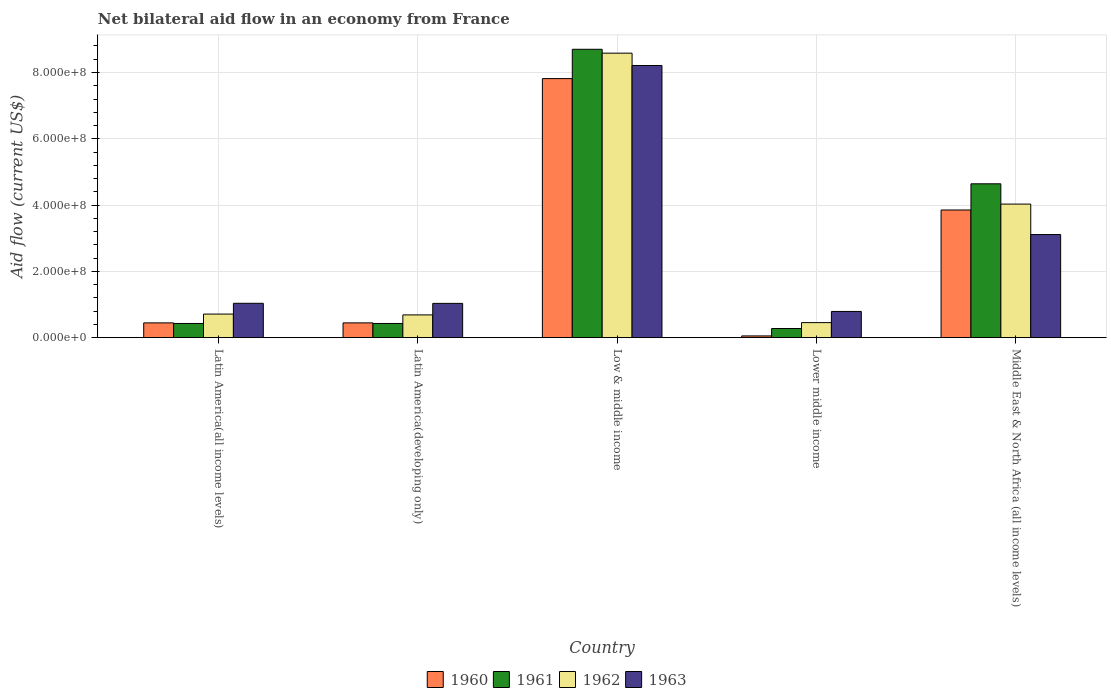How many bars are there on the 1st tick from the left?
Offer a terse response. 4. How many bars are there on the 3rd tick from the right?
Give a very brief answer. 4. What is the label of the 4th group of bars from the left?
Your answer should be very brief. Lower middle income. In how many cases, is the number of bars for a given country not equal to the number of legend labels?
Offer a very short reply. 0. What is the net bilateral aid flow in 1962 in Lower middle income?
Offer a very short reply. 4.54e+07. Across all countries, what is the maximum net bilateral aid flow in 1961?
Your answer should be compact. 8.70e+08. Across all countries, what is the minimum net bilateral aid flow in 1961?
Offer a terse response. 2.76e+07. In which country was the net bilateral aid flow in 1963 minimum?
Offer a very short reply. Lower middle income. What is the total net bilateral aid flow in 1962 in the graph?
Your response must be concise. 1.45e+09. What is the difference between the net bilateral aid flow in 1963 in Latin America(developing only) and that in Lower middle income?
Keep it short and to the point. 2.43e+07. What is the difference between the net bilateral aid flow in 1963 in Latin America(all income levels) and the net bilateral aid flow in 1962 in Lower middle income?
Provide a succinct answer. 5.83e+07. What is the average net bilateral aid flow in 1962 per country?
Ensure brevity in your answer.  2.89e+08. What is the difference between the net bilateral aid flow of/in 1963 and net bilateral aid flow of/in 1962 in Middle East & North Africa (all income levels)?
Offer a very short reply. -9.19e+07. Is the net bilateral aid flow in 1960 in Latin America(all income levels) less than that in Middle East & North Africa (all income levels)?
Your answer should be compact. Yes. Is the difference between the net bilateral aid flow in 1963 in Latin America(all income levels) and Middle East & North Africa (all income levels) greater than the difference between the net bilateral aid flow in 1962 in Latin America(all income levels) and Middle East & North Africa (all income levels)?
Make the answer very short. Yes. What is the difference between the highest and the second highest net bilateral aid flow in 1963?
Give a very brief answer. 7.17e+08. What is the difference between the highest and the lowest net bilateral aid flow in 1963?
Ensure brevity in your answer.  7.42e+08. What does the 4th bar from the right in Latin America(developing only) represents?
Provide a short and direct response. 1960. How many bars are there?
Your answer should be compact. 20. How many countries are there in the graph?
Make the answer very short. 5. How many legend labels are there?
Keep it short and to the point. 4. What is the title of the graph?
Give a very brief answer. Net bilateral aid flow in an economy from France. Does "1964" appear as one of the legend labels in the graph?
Keep it short and to the point. No. What is the Aid flow (current US$) in 1960 in Latin America(all income levels)?
Provide a succinct answer. 4.46e+07. What is the Aid flow (current US$) of 1961 in Latin America(all income levels)?
Your response must be concise. 4.28e+07. What is the Aid flow (current US$) of 1962 in Latin America(all income levels)?
Provide a succinct answer. 7.12e+07. What is the Aid flow (current US$) of 1963 in Latin America(all income levels)?
Offer a terse response. 1.04e+08. What is the Aid flow (current US$) in 1960 in Latin America(developing only)?
Give a very brief answer. 4.46e+07. What is the Aid flow (current US$) in 1961 in Latin America(developing only)?
Your response must be concise. 4.28e+07. What is the Aid flow (current US$) in 1962 in Latin America(developing only)?
Make the answer very short. 6.87e+07. What is the Aid flow (current US$) of 1963 in Latin America(developing only)?
Offer a terse response. 1.03e+08. What is the Aid flow (current US$) of 1960 in Low & middle income?
Your response must be concise. 7.82e+08. What is the Aid flow (current US$) in 1961 in Low & middle income?
Keep it short and to the point. 8.70e+08. What is the Aid flow (current US$) of 1962 in Low & middle income?
Offer a terse response. 8.58e+08. What is the Aid flow (current US$) of 1963 in Low & middle income?
Offer a terse response. 8.21e+08. What is the Aid flow (current US$) in 1960 in Lower middle income?
Your answer should be compact. 5.30e+06. What is the Aid flow (current US$) in 1961 in Lower middle income?
Your response must be concise. 2.76e+07. What is the Aid flow (current US$) in 1962 in Lower middle income?
Your response must be concise. 4.54e+07. What is the Aid flow (current US$) of 1963 in Lower middle income?
Offer a very short reply. 7.91e+07. What is the Aid flow (current US$) of 1960 in Middle East & North Africa (all income levels)?
Provide a succinct answer. 3.85e+08. What is the Aid flow (current US$) of 1961 in Middle East & North Africa (all income levels)?
Offer a terse response. 4.64e+08. What is the Aid flow (current US$) in 1962 in Middle East & North Africa (all income levels)?
Keep it short and to the point. 4.03e+08. What is the Aid flow (current US$) in 1963 in Middle East & North Africa (all income levels)?
Your response must be concise. 3.11e+08. Across all countries, what is the maximum Aid flow (current US$) in 1960?
Ensure brevity in your answer.  7.82e+08. Across all countries, what is the maximum Aid flow (current US$) in 1961?
Your answer should be compact. 8.70e+08. Across all countries, what is the maximum Aid flow (current US$) of 1962?
Offer a very short reply. 8.58e+08. Across all countries, what is the maximum Aid flow (current US$) in 1963?
Your answer should be very brief. 8.21e+08. Across all countries, what is the minimum Aid flow (current US$) in 1960?
Give a very brief answer. 5.30e+06. Across all countries, what is the minimum Aid flow (current US$) of 1961?
Make the answer very short. 2.76e+07. Across all countries, what is the minimum Aid flow (current US$) in 1962?
Your answer should be very brief. 4.54e+07. Across all countries, what is the minimum Aid flow (current US$) of 1963?
Your answer should be very brief. 7.91e+07. What is the total Aid flow (current US$) of 1960 in the graph?
Ensure brevity in your answer.  1.26e+09. What is the total Aid flow (current US$) in 1961 in the graph?
Provide a succinct answer. 1.45e+09. What is the total Aid flow (current US$) in 1962 in the graph?
Your answer should be compact. 1.45e+09. What is the total Aid flow (current US$) in 1963 in the graph?
Provide a succinct answer. 1.42e+09. What is the difference between the Aid flow (current US$) of 1960 in Latin America(all income levels) and that in Latin America(developing only)?
Offer a very short reply. 0. What is the difference between the Aid flow (current US$) of 1961 in Latin America(all income levels) and that in Latin America(developing only)?
Give a very brief answer. 0. What is the difference between the Aid flow (current US$) of 1962 in Latin America(all income levels) and that in Latin America(developing only)?
Provide a succinct answer. 2.50e+06. What is the difference between the Aid flow (current US$) in 1963 in Latin America(all income levels) and that in Latin America(developing only)?
Your response must be concise. 3.00e+05. What is the difference between the Aid flow (current US$) of 1960 in Latin America(all income levels) and that in Low & middle income?
Provide a short and direct response. -7.37e+08. What is the difference between the Aid flow (current US$) of 1961 in Latin America(all income levels) and that in Low & middle income?
Your answer should be very brief. -8.27e+08. What is the difference between the Aid flow (current US$) in 1962 in Latin America(all income levels) and that in Low & middle income?
Keep it short and to the point. -7.87e+08. What is the difference between the Aid flow (current US$) in 1963 in Latin America(all income levels) and that in Low & middle income?
Your answer should be very brief. -7.17e+08. What is the difference between the Aid flow (current US$) in 1960 in Latin America(all income levels) and that in Lower middle income?
Give a very brief answer. 3.93e+07. What is the difference between the Aid flow (current US$) of 1961 in Latin America(all income levels) and that in Lower middle income?
Keep it short and to the point. 1.52e+07. What is the difference between the Aid flow (current US$) in 1962 in Latin America(all income levels) and that in Lower middle income?
Your answer should be very brief. 2.58e+07. What is the difference between the Aid flow (current US$) in 1963 in Latin America(all income levels) and that in Lower middle income?
Offer a very short reply. 2.46e+07. What is the difference between the Aid flow (current US$) in 1960 in Latin America(all income levels) and that in Middle East & North Africa (all income levels)?
Ensure brevity in your answer.  -3.41e+08. What is the difference between the Aid flow (current US$) in 1961 in Latin America(all income levels) and that in Middle East & North Africa (all income levels)?
Make the answer very short. -4.21e+08. What is the difference between the Aid flow (current US$) in 1962 in Latin America(all income levels) and that in Middle East & North Africa (all income levels)?
Keep it short and to the point. -3.32e+08. What is the difference between the Aid flow (current US$) in 1963 in Latin America(all income levels) and that in Middle East & North Africa (all income levels)?
Give a very brief answer. -2.07e+08. What is the difference between the Aid flow (current US$) in 1960 in Latin America(developing only) and that in Low & middle income?
Provide a short and direct response. -7.37e+08. What is the difference between the Aid flow (current US$) of 1961 in Latin America(developing only) and that in Low & middle income?
Your response must be concise. -8.27e+08. What is the difference between the Aid flow (current US$) of 1962 in Latin America(developing only) and that in Low & middle income?
Offer a very short reply. -7.90e+08. What is the difference between the Aid flow (current US$) of 1963 in Latin America(developing only) and that in Low & middle income?
Give a very brief answer. -7.18e+08. What is the difference between the Aid flow (current US$) in 1960 in Latin America(developing only) and that in Lower middle income?
Your answer should be very brief. 3.93e+07. What is the difference between the Aid flow (current US$) in 1961 in Latin America(developing only) and that in Lower middle income?
Provide a short and direct response. 1.52e+07. What is the difference between the Aid flow (current US$) in 1962 in Latin America(developing only) and that in Lower middle income?
Your answer should be compact. 2.33e+07. What is the difference between the Aid flow (current US$) in 1963 in Latin America(developing only) and that in Lower middle income?
Ensure brevity in your answer.  2.43e+07. What is the difference between the Aid flow (current US$) in 1960 in Latin America(developing only) and that in Middle East & North Africa (all income levels)?
Keep it short and to the point. -3.41e+08. What is the difference between the Aid flow (current US$) in 1961 in Latin America(developing only) and that in Middle East & North Africa (all income levels)?
Make the answer very short. -4.21e+08. What is the difference between the Aid flow (current US$) in 1962 in Latin America(developing only) and that in Middle East & North Africa (all income levels)?
Provide a succinct answer. -3.34e+08. What is the difference between the Aid flow (current US$) of 1963 in Latin America(developing only) and that in Middle East & North Africa (all income levels)?
Offer a terse response. -2.08e+08. What is the difference between the Aid flow (current US$) in 1960 in Low & middle income and that in Lower middle income?
Keep it short and to the point. 7.76e+08. What is the difference between the Aid flow (current US$) of 1961 in Low & middle income and that in Lower middle income?
Offer a very short reply. 8.42e+08. What is the difference between the Aid flow (current US$) in 1962 in Low & middle income and that in Lower middle income?
Provide a succinct answer. 8.13e+08. What is the difference between the Aid flow (current US$) in 1963 in Low & middle income and that in Lower middle income?
Give a very brief answer. 7.42e+08. What is the difference between the Aid flow (current US$) in 1960 in Low & middle income and that in Middle East & North Africa (all income levels)?
Your response must be concise. 3.96e+08. What is the difference between the Aid flow (current US$) in 1961 in Low & middle income and that in Middle East & North Africa (all income levels)?
Make the answer very short. 4.06e+08. What is the difference between the Aid flow (current US$) of 1962 in Low & middle income and that in Middle East & North Africa (all income levels)?
Offer a terse response. 4.55e+08. What is the difference between the Aid flow (current US$) of 1963 in Low & middle income and that in Middle East & North Africa (all income levels)?
Provide a succinct answer. 5.10e+08. What is the difference between the Aid flow (current US$) of 1960 in Lower middle income and that in Middle East & North Africa (all income levels)?
Keep it short and to the point. -3.80e+08. What is the difference between the Aid flow (current US$) in 1961 in Lower middle income and that in Middle East & North Africa (all income levels)?
Keep it short and to the point. -4.37e+08. What is the difference between the Aid flow (current US$) of 1962 in Lower middle income and that in Middle East & North Africa (all income levels)?
Your response must be concise. -3.58e+08. What is the difference between the Aid flow (current US$) in 1963 in Lower middle income and that in Middle East & North Africa (all income levels)?
Provide a short and direct response. -2.32e+08. What is the difference between the Aid flow (current US$) of 1960 in Latin America(all income levels) and the Aid flow (current US$) of 1961 in Latin America(developing only)?
Offer a very short reply. 1.80e+06. What is the difference between the Aid flow (current US$) of 1960 in Latin America(all income levels) and the Aid flow (current US$) of 1962 in Latin America(developing only)?
Keep it short and to the point. -2.41e+07. What is the difference between the Aid flow (current US$) of 1960 in Latin America(all income levels) and the Aid flow (current US$) of 1963 in Latin America(developing only)?
Your response must be concise. -5.88e+07. What is the difference between the Aid flow (current US$) of 1961 in Latin America(all income levels) and the Aid flow (current US$) of 1962 in Latin America(developing only)?
Keep it short and to the point. -2.59e+07. What is the difference between the Aid flow (current US$) of 1961 in Latin America(all income levels) and the Aid flow (current US$) of 1963 in Latin America(developing only)?
Provide a succinct answer. -6.06e+07. What is the difference between the Aid flow (current US$) of 1962 in Latin America(all income levels) and the Aid flow (current US$) of 1963 in Latin America(developing only)?
Your answer should be compact. -3.22e+07. What is the difference between the Aid flow (current US$) in 1960 in Latin America(all income levels) and the Aid flow (current US$) in 1961 in Low & middle income?
Offer a very short reply. -8.25e+08. What is the difference between the Aid flow (current US$) of 1960 in Latin America(all income levels) and the Aid flow (current US$) of 1962 in Low & middle income?
Provide a succinct answer. -8.14e+08. What is the difference between the Aid flow (current US$) of 1960 in Latin America(all income levels) and the Aid flow (current US$) of 1963 in Low & middle income?
Make the answer very short. -7.76e+08. What is the difference between the Aid flow (current US$) of 1961 in Latin America(all income levels) and the Aid flow (current US$) of 1962 in Low & middle income?
Provide a short and direct response. -8.16e+08. What is the difference between the Aid flow (current US$) in 1961 in Latin America(all income levels) and the Aid flow (current US$) in 1963 in Low & middle income?
Provide a succinct answer. -7.78e+08. What is the difference between the Aid flow (current US$) of 1962 in Latin America(all income levels) and the Aid flow (current US$) of 1963 in Low & middle income?
Your answer should be compact. -7.50e+08. What is the difference between the Aid flow (current US$) of 1960 in Latin America(all income levels) and the Aid flow (current US$) of 1961 in Lower middle income?
Ensure brevity in your answer.  1.70e+07. What is the difference between the Aid flow (current US$) in 1960 in Latin America(all income levels) and the Aid flow (current US$) in 1962 in Lower middle income?
Ensure brevity in your answer.  -8.00e+05. What is the difference between the Aid flow (current US$) in 1960 in Latin America(all income levels) and the Aid flow (current US$) in 1963 in Lower middle income?
Give a very brief answer. -3.45e+07. What is the difference between the Aid flow (current US$) of 1961 in Latin America(all income levels) and the Aid flow (current US$) of 1962 in Lower middle income?
Your answer should be very brief. -2.60e+06. What is the difference between the Aid flow (current US$) of 1961 in Latin America(all income levels) and the Aid flow (current US$) of 1963 in Lower middle income?
Offer a very short reply. -3.63e+07. What is the difference between the Aid flow (current US$) in 1962 in Latin America(all income levels) and the Aid flow (current US$) in 1963 in Lower middle income?
Your answer should be compact. -7.90e+06. What is the difference between the Aid flow (current US$) of 1960 in Latin America(all income levels) and the Aid flow (current US$) of 1961 in Middle East & North Africa (all income levels)?
Your answer should be very brief. -4.20e+08. What is the difference between the Aid flow (current US$) in 1960 in Latin America(all income levels) and the Aid flow (current US$) in 1962 in Middle East & North Africa (all income levels)?
Provide a succinct answer. -3.58e+08. What is the difference between the Aid flow (current US$) of 1960 in Latin America(all income levels) and the Aid flow (current US$) of 1963 in Middle East & North Africa (all income levels)?
Provide a succinct answer. -2.66e+08. What is the difference between the Aid flow (current US$) in 1961 in Latin America(all income levels) and the Aid flow (current US$) in 1962 in Middle East & North Africa (all income levels)?
Your response must be concise. -3.60e+08. What is the difference between the Aid flow (current US$) in 1961 in Latin America(all income levels) and the Aid flow (current US$) in 1963 in Middle East & North Africa (all income levels)?
Provide a short and direct response. -2.68e+08. What is the difference between the Aid flow (current US$) in 1962 in Latin America(all income levels) and the Aid flow (current US$) in 1963 in Middle East & North Africa (all income levels)?
Make the answer very short. -2.40e+08. What is the difference between the Aid flow (current US$) in 1960 in Latin America(developing only) and the Aid flow (current US$) in 1961 in Low & middle income?
Provide a succinct answer. -8.25e+08. What is the difference between the Aid flow (current US$) of 1960 in Latin America(developing only) and the Aid flow (current US$) of 1962 in Low & middle income?
Provide a short and direct response. -8.14e+08. What is the difference between the Aid flow (current US$) in 1960 in Latin America(developing only) and the Aid flow (current US$) in 1963 in Low & middle income?
Provide a succinct answer. -7.76e+08. What is the difference between the Aid flow (current US$) of 1961 in Latin America(developing only) and the Aid flow (current US$) of 1962 in Low & middle income?
Your answer should be compact. -8.16e+08. What is the difference between the Aid flow (current US$) in 1961 in Latin America(developing only) and the Aid flow (current US$) in 1963 in Low & middle income?
Provide a short and direct response. -7.78e+08. What is the difference between the Aid flow (current US$) in 1962 in Latin America(developing only) and the Aid flow (current US$) in 1963 in Low & middle income?
Provide a short and direct response. -7.52e+08. What is the difference between the Aid flow (current US$) in 1960 in Latin America(developing only) and the Aid flow (current US$) in 1961 in Lower middle income?
Provide a short and direct response. 1.70e+07. What is the difference between the Aid flow (current US$) of 1960 in Latin America(developing only) and the Aid flow (current US$) of 1962 in Lower middle income?
Provide a short and direct response. -8.00e+05. What is the difference between the Aid flow (current US$) of 1960 in Latin America(developing only) and the Aid flow (current US$) of 1963 in Lower middle income?
Keep it short and to the point. -3.45e+07. What is the difference between the Aid flow (current US$) of 1961 in Latin America(developing only) and the Aid flow (current US$) of 1962 in Lower middle income?
Your response must be concise. -2.60e+06. What is the difference between the Aid flow (current US$) of 1961 in Latin America(developing only) and the Aid flow (current US$) of 1963 in Lower middle income?
Your answer should be very brief. -3.63e+07. What is the difference between the Aid flow (current US$) in 1962 in Latin America(developing only) and the Aid flow (current US$) in 1963 in Lower middle income?
Offer a very short reply. -1.04e+07. What is the difference between the Aid flow (current US$) of 1960 in Latin America(developing only) and the Aid flow (current US$) of 1961 in Middle East & North Africa (all income levels)?
Give a very brief answer. -4.20e+08. What is the difference between the Aid flow (current US$) of 1960 in Latin America(developing only) and the Aid flow (current US$) of 1962 in Middle East & North Africa (all income levels)?
Offer a very short reply. -3.58e+08. What is the difference between the Aid flow (current US$) in 1960 in Latin America(developing only) and the Aid flow (current US$) in 1963 in Middle East & North Africa (all income levels)?
Provide a short and direct response. -2.66e+08. What is the difference between the Aid flow (current US$) in 1961 in Latin America(developing only) and the Aid flow (current US$) in 1962 in Middle East & North Africa (all income levels)?
Offer a very short reply. -3.60e+08. What is the difference between the Aid flow (current US$) of 1961 in Latin America(developing only) and the Aid flow (current US$) of 1963 in Middle East & North Africa (all income levels)?
Make the answer very short. -2.68e+08. What is the difference between the Aid flow (current US$) of 1962 in Latin America(developing only) and the Aid flow (current US$) of 1963 in Middle East & North Africa (all income levels)?
Provide a succinct answer. -2.42e+08. What is the difference between the Aid flow (current US$) of 1960 in Low & middle income and the Aid flow (current US$) of 1961 in Lower middle income?
Provide a short and direct response. 7.54e+08. What is the difference between the Aid flow (current US$) of 1960 in Low & middle income and the Aid flow (current US$) of 1962 in Lower middle income?
Give a very brief answer. 7.36e+08. What is the difference between the Aid flow (current US$) in 1960 in Low & middle income and the Aid flow (current US$) in 1963 in Lower middle income?
Offer a very short reply. 7.02e+08. What is the difference between the Aid flow (current US$) of 1961 in Low & middle income and the Aid flow (current US$) of 1962 in Lower middle income?
Your answer should be compact. 8.25e+08. What is the difference between the Aid flow (current US$) of 1961 in Low & middle income and the Aid flow (current US$) of 1963 in Lower middle income?
Provide a succinct answer. 7.91e+08. What is the difference between the Aid flow (current US$) in 1962 in Low & middle income and the Aid flow (current US$) in 1963 in Lower middle income?
Your answer should be very brief. 7.79e+08. What is the difference between the Aid flow (current US$) of 1960 in Low & middle income and the Aid flow (current US$) of 1961 in Middle East & North Africa (all income levels)?
Give a very brief answer. 3.17e+08. What is the difference between the Aid flow (current US$) of 1960 in Low & middle income and the Aid flow (current US$) of 1962 in Middle East & North Africa (all income levels)?
Your answer should be very brief. 3.79e+08. What is the difference between the Aid flow (current US$) in 1960 in Low & middle income and the Aid flow (current US$) in 1963 in Middle East & North Africa (all income levels)?
Ensure brevity in your answer.  4.70e+08. What is the difference between the Aid flow (current US$) in 1961 in Low & middle income and the Aid flow (current US$) in 1962 in Middle East & North Africa (all income levels)?
Your answer should be very brief. 4.67e+08. What is the difference between the Aid flow (current US$) in 1961 in Low & middle income and the Aid flow (current US$) in 1963 in Middle East & North Africa (all income levels)?
Provide a succinct answer. 5.59e+08. What is the difference between the Aid flow (current US$) of 1962 in Low & middle income and the Aid flow (current US$) of 1963 in Middle East & North Africa (all income levels)?
Give a very brief answer. 5.47e+08. What is the difference between the Aid flow (current US$) in 1960 in Lower middle income and the Aid flow (current US$) in 1961 in Middle East & North Africa (all income levels)?
Provide a succinct answer. -4.59e+08. What is the difference between the Aid flow (current US$) of 1960 in Lower middle income and the Aid flow (current US$) of 1962 in Middle East & North Africa (all income levels)?
Provide a succinct answer. -3.98e+08. What is the difference between the Aid flow (current US$) of 1960 in Lower middle income and the Aid flow (current US$) of 1963 in Middle East & North Africa (all income levels)?
Offer a very short reply. -3.06e+08. What is the difference between the Aid flow (current US$) of 1961 in Lower middle income and the Aid flow (current US$) of 1962 in Middle East & North Africa (all income levels)?
Your response must be concise. -3.75e+08. What is the difference between the Aid flow (current US$) of 1961 in Lower middle income and the Aid flow (current US$) of 1963 in Middle East & North Africa (all income levels)?
Your answer should be compact. -2.84e+08. What is the difference between the Aid flow (current US$) of 1962 in Lower middle income and the Aid flow (current US$) of 1963 in Middle East & North Africa (all income levels)?
Offer a terse response. -2.66e+08. What is the average Aid flow (current US$) of 1960 per country?
Make the answer very short. 2.52e+08. What is the average Aid flow (current US$) of 1961 per country?
Your answer should be very brief. 2.89e+08. What is the average Aid flow (current US$) in 1962 per country?
Provide a succinct answer. 2.89e+08. What is the average Aid flow (current US$) in 1963 per country?
Ensure brevity in your answer.  2.84e+08. What is the difference between the Aid flow (current US$) in 1960 and Aid flow (current US$) in 1961 in Latin America(all income levels)?
Your answer should be very brief. 1.80e+06. What is the difference between the Aid flow (current US$) of 1960 and Aid flow (current US$) of 1962 in Latin America(all income levels)?
Your answer should be compact. -2.66e+07. What is the difference between the Aid flow (current US$) in 1960 and Aid flow (current US$) in 1963 in Latin America(all income levels)?
Your answer should be very brief. -5.91e+07. What is the difference between the Aid flow (current US$) in 1961 and Aid flow (current US$) in 1962 in Latin America(all income levels)?
Make the answer very short. -2.84e+07. What is the difference between the Aid flow (current US$) of 1961 and Aid flow (current US$) of 1963 in Latin America(all income levels)?
Your response must be concise. -6.09e+07. What is the difference between the Aid flow (current US$) of 1962 and Aid flow (current US$) of 1963 in Latin America(all income levels)?
Your answer should be very brief. -3.25e+07. What is the difference between the Aid flow (current US$) of 1960 and Aid flow (current US$) of 1961 in Latin America(developing only)?
Your answer should be very brief. 1.80e+06. What is the difference between the Aid flow (current US$) in 1960 and Aid flow (current US$) in 1962 in Latin America(developing only)?
Give a very brief answer. -2.41e+07. What is the difference between the Aid flow (current US$) of 1960 and Aid flow (current US$) of 1963 in Latin America(developing only)?
Keep it short and to the point. -5.88e+07. What is the difference between the Aid flow (current US$) in 1961 and Aid flow (current US$) in 1962 in Latin America(developing only)?
Ensure brevity in your answer.  -2.59e+07. What is the difference between the Aid flow (current US$) in 1961 and Aid flow (current US$) in 1963 in Latin America(developing only)?
Give a very brief answer. -6.06e+07. What is the difference between the Aid flow (current US$) in 1962 and Aid flow (current US$) in 1963 in Latin America(developing only)?
Ensure brevity in your answer.  -3.47e+07. What is the difference between the Aid flow (current US$) in 1960 and Aid flow (current US$) in 1961 in Low & middle income?
Give a very brief answer. -8.84e+07. What is the difference between the Aid flow (current US$) in 1960 and Aid flow (current US$) in 1962 in Low & middle income?
Your answer should be compact. -7.67e+07. What is the difference between the Aid flow (current US$) of 1960 and Aid flow (current US$) of 1963 in Low & middle income?
Provide a short and direct response. -3.95e+07. What is the difference between the Aid flow (current US$) of 1961 and Aid flow (current US$) of 1962 in Low & middle income?
Your response must be concise. 1.17e+07. What is the difference between the Aid flow (current US$) of 1961 and Aid flow (current US$) of 1963 in Low & middle income?
Keep it short and to the point. 4.89e+07. What is the difference between the Aid flow (current US$) of 1962 and Aid flow (current US$) of 1963 in Low & middle income?
Keep it short and to the point. 3.72e+07. What is the difference between the Aid flow (current US$) of 1960 and Aid flow (current US$) of 1961 in Lower middle income?
Keep it short and to the point. -2.23e+07. What is the difference between the Aid flow (current US$) of 1960 and Aid flow (current US$) of 1962 in Lower middle income?
Ensure brevity in your answer.  -4.01e+07. What is the difference between the Aid flow (current US$) of 1960 and Aid flow (current US$) of 1963 in Lower middle income?
Provide a succinct answer. -7.38e+07. What is the difference between the Aid flow (current US$) of 1961 and Aid flow (current US$) of 1962 in Lower middle income?
Keep it short and to the point. -1.78e+07. What is the difference between the Aid flow (current US$) of 1961 and Aid flow (current US$) of 1963 in Lower middle income?
Make the answer very short. -5.15e+07. What is the difference between the Aid flow (current US$) in 1962 and Aid flow (current US$) in 1963 in Lower middle income?
Provide a short and direct response. -3.37e+07. What is the difference between the Aid flow (current US$) of 1960 and Aid flow (current US$) of 1961 in Middle East & North Africa (all income levels)?
Ensure brevity in your answer.  -7.90e+07. What is the difference between the Aid flow (current US$) of 1960 and Aid flow (current US$) of 1962 in Middle East & North Africa (all income levels)?
Offer a terse response. -1.78e+07. What is the difference between the Aid flow (current US$) in 1960 and Aid flow (current US$) in 1963 in Middle East & North Africa (all income levels)?
Provide a succinct answer. 7.41e+07. What is the difference between the Aid flow (current US$) of 1961 and Aid flow (current US$) of 1962 in Middle East & North Africa (all income levels)?
Your answer should be compact. 6.12e+07. What is the difference between the Aid flow (current US$) in 1961 and Aid flow (current US$) in 1963 in Middle East & North Africa (all income levels)?
Provide a succinct answer. 1.53e+08. What is the difference between the Aid flow (current US$) of 1962 and Aid flow (current US$) of 1963 in Middle East & North Africa (all income levels)?
Your answer should be very brief. 9.19e+07. What is the ratio of the Aid flow (current US$) in 1962 in Latin America(all income levels) to that in Latin America(developing only)?
Provide a short and direct response. 1.04. What is the ratio of the Aid flow (current US$) in 1963 in Latin America(all income levels) to that in Latin America(developing only)?
Your answer should be compact. 1. What is the ratio of the Aid flow (current US$) in 1960 in Latin America(all income levels) to that in Low & middle income?
Provide a succinct answer. 0.06. What is the ratio of the Aid flow (current US$) of 1961 in Latin America(all income levels) to that in Low & middle income?
Your answer should be compact. 0.05. What is the ratio of the Aid flow (current US$) in 1962 in Latin America(all income levels) to that in Low & middle income?
Provide a short and direct response. 0.08. What is the ratio of the Aid flow (current US$) in 1963 in Latin America(all income levels) to that in Low & middle income?
Ensure brevity in your answer.  0.13. What is the ratio of the Aid flow (current US$) of 1960 in Latin America(all income levels) to that in Lower middle income?
Your answer should be very brief. 8.42. What is the ratio of the Aid flow (current US$) of 1961 in Latin America(all income levels) to that in Lower middle income?
Keep it short and to the point. 1.55. What is the ratio of the Aid flow (current US$) of 1962 in Latin America(all income levels) to that in Lower middle income?
Provide a succinct answer. 1.57. What is the ratio of the Aid flow (current US$) of 1963 in Latin America(all income levels) to that in Lower middle income?
Your answer should be compact. 1.31. What is the ratio of the Aid flow (current US$) of 1960 in Latin America(all income levels) to that in Middle East & North Africa (all income levels)?
Offer a very short reply. 0.12. What is the ratio of the Aid flow (current US$) of 1961 in Latin America(all income levels) to that in Middle East & North Africa (all income levels)?
Your answer should be compact. 0.09. What is the ratio of the Aid flow (current US$) in 1962 in Latin America(all income levels) to that in Middle East & North Africa (all income levels)?
Your answer should be very brief. 0.18. What is the ratio of the Aid flow (current US$) in 1960 in Latin America(developing only) to that in Low & middle income?
Ensure brevity in your answer.  0.06. What is the ratio of the Aid flow (current US$) of 1961 in Latin America(developing only) to that in Low & middle income?
Your answer should be very brief. 0.05. What is the ratio of the Aid flow (current US$) of 1963 in Latin America(developing only) to that in Low & middle income?
Ensure brevity in your answer.  0.13. What is the ratio of the Aid flow (current US$) in 1960 in Latin America(developing only) to that in Lower middle income?
Your answer should be compact. 8.42. What is the ratio of the Aid flow (current US$) of 1961 in Latin America(developing only) to that in Lower middle income?
Provide a short and direct response. 1.55. What is the ratio of the Aid flow (current US$) in 1962 in Latin America(developing only) to that in Lower middle income?
Your response must be concise. 1.51. What is the ratio of the Aid flow (current US$) in 1963 in Latin America(developing only) to that in Lower middle income?
Keep it short and to the point. 1.31. What is the ratio of the Aid flow (current US$) in 1960 in Latin America(developing only) to that in Middle East & North Africa (all income levels)?
Your answer should be very brief. 0.12. What is the ratio of the Aid flow (current US$) in 1961 in Latin America(developing only) to that in Middle East & North Africa (all income levels)?
Provide a short and direct response. 0.09. What is the ratio of the Aid flow (current US$) of 1962 in Latin America(developing only) to that in Middle East & North Africa (all income levels)?
Offer a very short reply. 0.17. What is the ratio of the Aid flow (current US$) in 1963 in Latin America(developing only) to that in Middle East & North Africa (all income levels)?
Your answer should be very brief. 0.33. What is the ratio of the Aid flow (current US$) of 1960 in Low & middle income to that in Lower middle income?
Provide a succinct answer. 147.47. What is the ratio of the Aid flow (current US$) in 1961 in Low & middle income to that in Lower middle income?
Your answer should be very brief. 31.52. What is the ratio of the Aid flow (current US$) of 1962 in Low & middle income to that in Lower middle income?
Provide a succinct answer. 18.91. What is the ratio of the Aid flow (current US$) in 1963 in Low & middle income to that in Lower middle income?
Provide a succinct answer. 10.38. What is the ratio of the Aid flow (current US$) of 1960 in Low & middle income to that in Middle East & North Africa (all income levels)?
Your answer should be very brief. 2.03. What is the ratio of the Aid flow (current US$) of 1961 in Low & middle income to that in Middle East & North Africa (all income levels)?
Ensure brevity in your answer.  1.87. What is the ratio of the Aid flow (current US$) in 1962 in Low & middle income to that in Middle East & North Africa (all income levels)?
Your answer should be compact. 2.13. What is the ratio of the Aid flow (current US$) in 1963 in Low & middle income to that in Middle East & North Africa (all income levels)?
Your answer should be compact. 2.64. What is the ratio of the Aid flow (current US$) in 1960 in Lower middle income to that in Middle East & North Africa (all income levels)?
Ensure brevity in your answer.  0.01. What is the ratio of the Aid flow (current US$) of 1961 in Lower middle income to that in Middle East & North Africa (all income levels)?
Ensure brevity in your answer.  0.06. What is the ratio of the Aid flow (current US$) in 1962 in Lower middle income to that in Middle East & North Africa (all income levels)?
Your response must be concise. 0.11. What is the ratio of the Aid flow (current US$) in 1963 in Lower middle income to that in Middle East & North Africa (all income levels)?
Provide a short and direct response. 0.25. What is the difference between the highest and the second highest Aid flow (current US$) of 1960?
Give a very brief answer. 3.96e+08. What is the difference between the highest and the second highest Aid flow (current US$) in 1961?
Offer a terse response. 4.06e+08. What is the difference between the highest and the second highest Aid flow (current US$) of 1962?
Keep it short and to the point. 4.55e+08. What is the difference between the highest and the second highest Aid flow (current US$) of 1963?
Offer a terse response. 5.10e+08. What is the difference between the highest and the lowest Aid flow (current US$) of 1960?
Your answer should be compact. 7.76e+08. What is the difference between the highest and the lowest Aid flow (current US$) of 1961?
Your answer should be compact. 8.42e+08. What is the difference between the highest and the lowest Aid flow (current US$) in 1962?
Give a very brief answer. 8.13e+08. What is the difference between the highest and the lowest Aid flow (current US$) of 1963?
Offer a very short reply. 7.42e+08. 